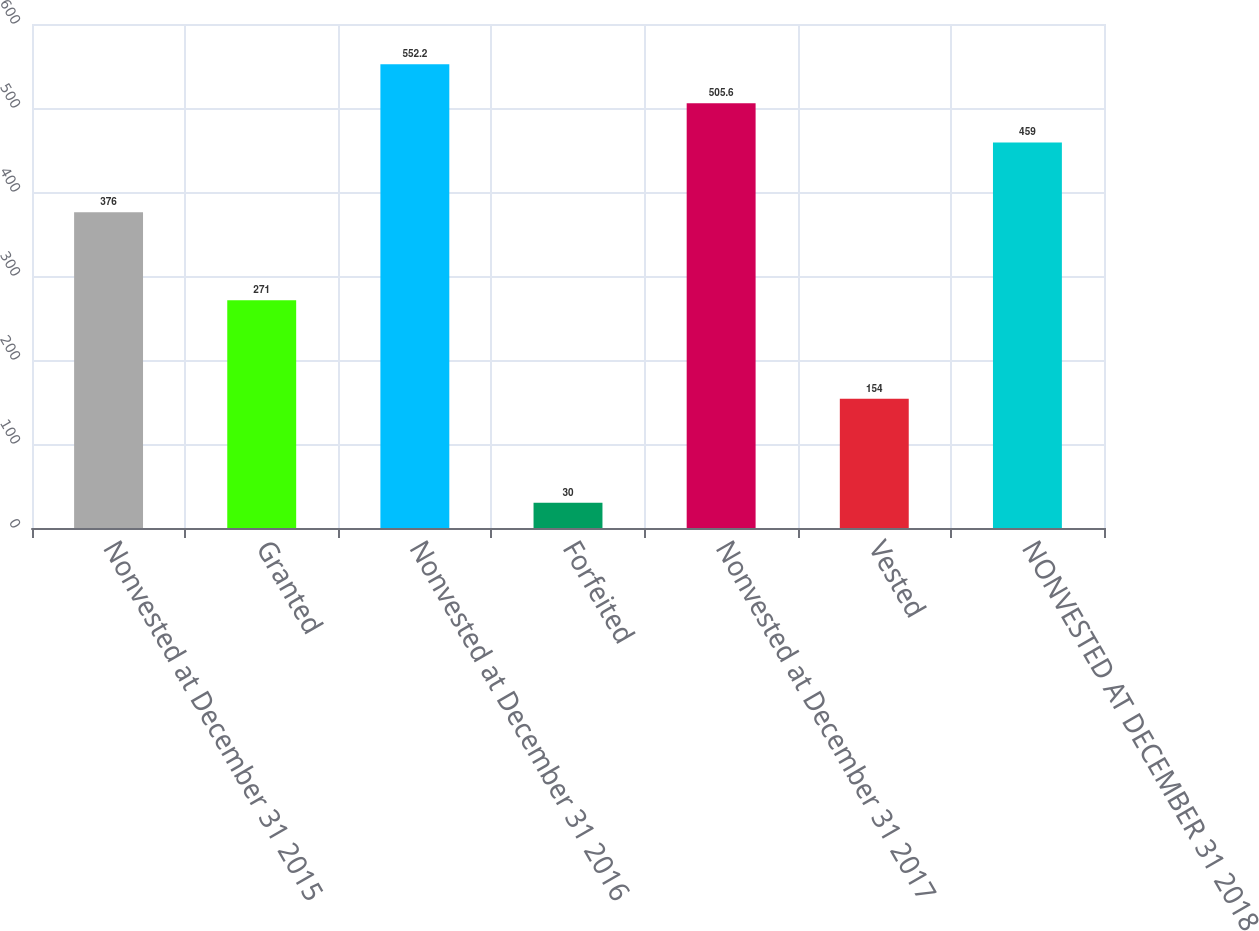<chart> <loc_0><loc_0><loc_500><loc_500><bar_chart><fcel>Nonvested at December 31 2015<fcel>Granted<fcel>Nonvested at December 31 2016<fcel>Forfeited<fcel>Nonvested at December 31 2017<fcel>Vested<fcel>NONVESTED AT DECEMBER 31 2018<nl><fcel>376<fcel>271<fcel>552.2<fcel>30<fcel>505.6<fcel>154<fcel>459<nl></chart> 